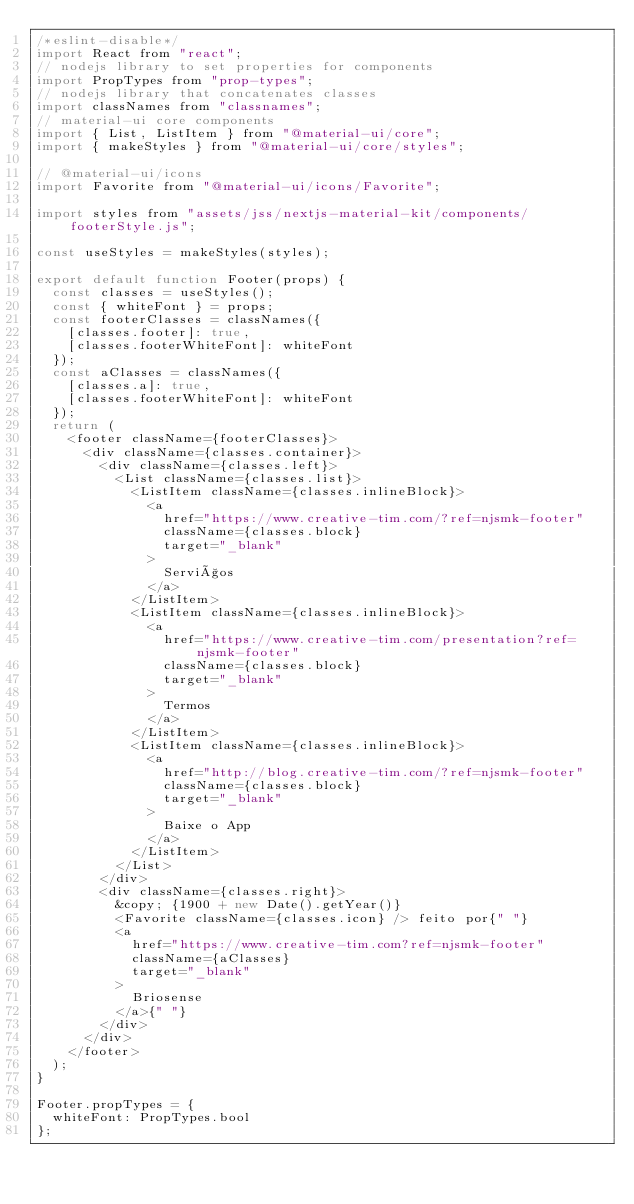<code> <loc_0><loc_0><loc_500><loc_500><_JavaScript_>/*eslint-disable*/
import React from "react";
// nodejs library to set properties for components
import PropTypes from "prop-types";
// nodejs library that concatenates classes
import classNames from "classnames";
// material-ui core components
import { List, ListItem } from "@material-ui/core";
import { makeStyles } from "@material-ui/core/styles";

// @material-ui/icons
import Favorite from "@material-ui/icons/Favorite";

import styles from "assets/jss/nextjs-material-kit/components/footerStyle.js";

const useStyles = makeStyles(styles);

export default function Footer(props) {
  const classes = useStyles();
  const { whiteFont } = props;
  const footerClasses = classNames({
    [classes.footer]: true,
    [classes.footerWhiteFont]: whiteFont
  });
  const aClasses = classNames({
    [classes.a]: true,
    [classes.footerWhiteFont]: whiteFont
  });
  return (
    <footer className={footerClasses}>
      <div className={classes.container}>
        <div className={classes.left}>
          <List className={classes.list}>
            <ListItem className={classes.inlineBlock}>
              <a
                href="https://www.creative-tim.com/?ref=njsmk-footer"
                className={classes.block}
                target="_blank"
              >
                Serviços
              </a>
            </ListItem>
            <ListItem className={classes.inlineBlock}>
              <a
                href="https://www.creative-tim.com/presentation?ref=njsmk-footer"
                className={classes.block}
                target="_blank"
              >
                Termos
              </a>
            </ListItem>
            <ListItem className={classes.inlineBlock}>
              <a
                href="http://blog.creative-tim.com/?ref=njsmk-footer"
                className={classes.block}
                target="_blank"
              >
                Baixe o App
              </a>
            </ListItem>
          </List>
        </div>
        <div className={classes.right}>
          &copy; {1900 + new Date().getYear()}
          <Favorite className={classes.icon} /> feito por{" "}
          <a
            href="https://www.creative-tim.com?ref=njsmk-footer"
            className={aClasses}
            target="_blank"
          >
            Briosense
          </a>{" "}
        </div>
      </div>
    </footer>
  );
}

Footer.propTypes = {
  whiteFont: PropTypes.bool
};
</code> 